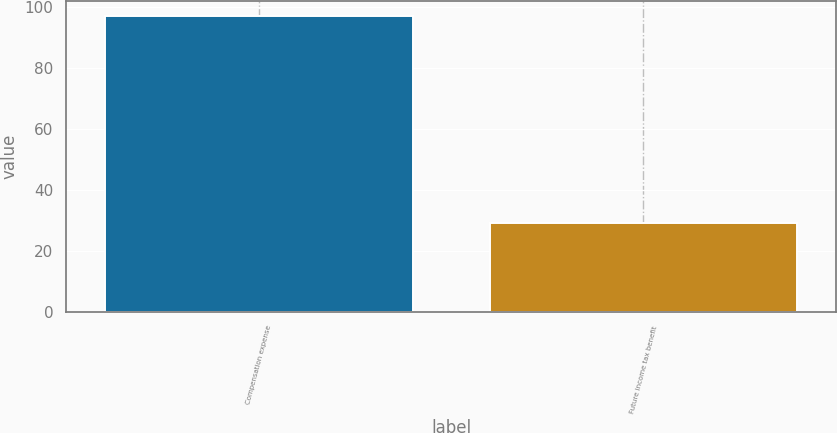<chart> <loc_0><loc_0><loc_500><loc_500><bar_chart><fcel>Compensation expense<fcel>Future income tax benefit<nl><fcel>97<fcel>29<nl></chart> 